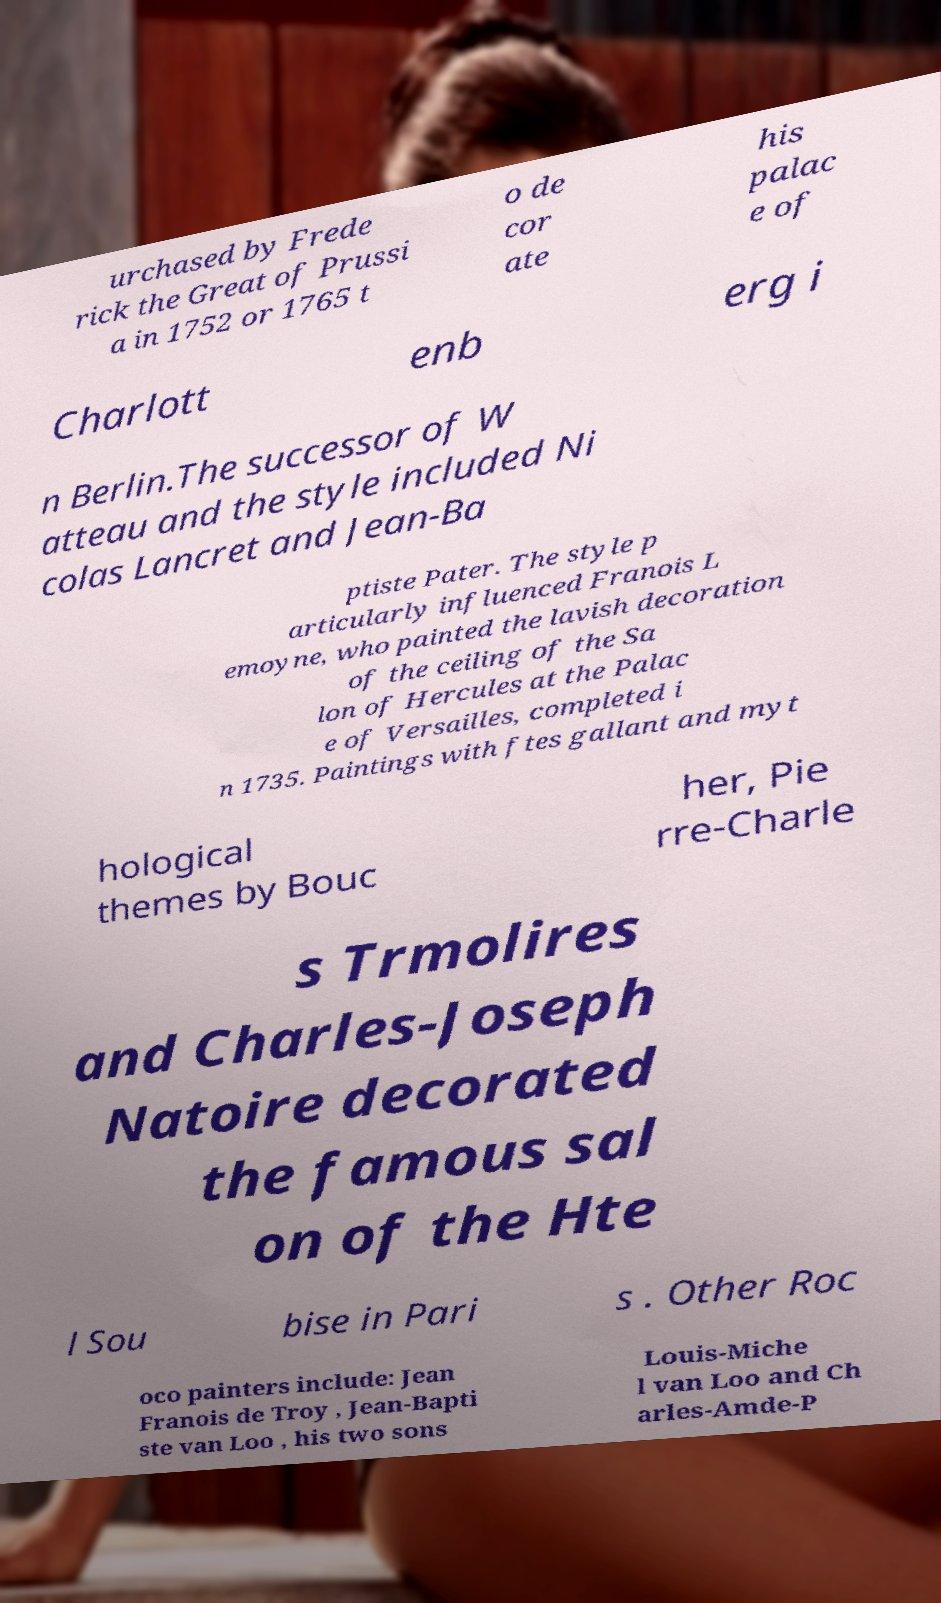Please identify and transcribe the text found in this image. urchased by Frede rick the Great of Prussi a in 1752 or 1765 t o de cor ate his palac e of Charlott enb erg i n Berlin.The successor of W atteau and the style included Ni colas Lancret and Jean-Ba ptiste Pater. The style p articularly influenced Franois L emoyne, who painted the lavish decoration of the ceiling of the Sa lon of Hercules at the Palac e of Versailles, completed i n 1735. Paintings with ftes gallant and myt hological themes by Bouc her, Pie rre-Charle s Trmolires and Charles-Joseph Natoire decorated the famous sal on of the Hte l Sou bise in Pari s . Other Roc oco painters include: Jean Franois de Troy , Jean-Bapti ste van Loo , his two sons Louis-Miche l van Loo and Ch arles-Amde-P 